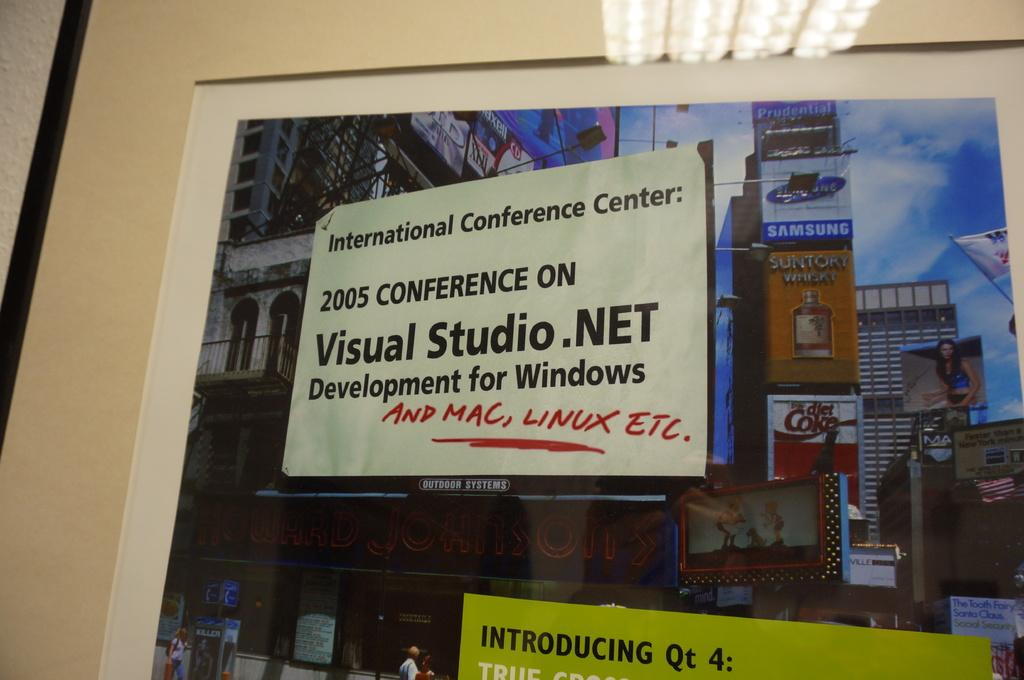<image>
Present a compact description of the photo's key features. a sign from the visual stuio . net 